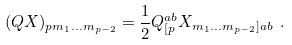Convert formula to latex. <formula><loc_0><loc_0><loc_500><loc_500>( Q X ) _ { p m _ { 1 } \dots m _ { p - 2 } } = \frac { 1 } { 2 } Q ^ { a b } _ { [ p } X _ { m _ { 1 } \dots m _ { p - 2 } ] a b } \ .</formula> 